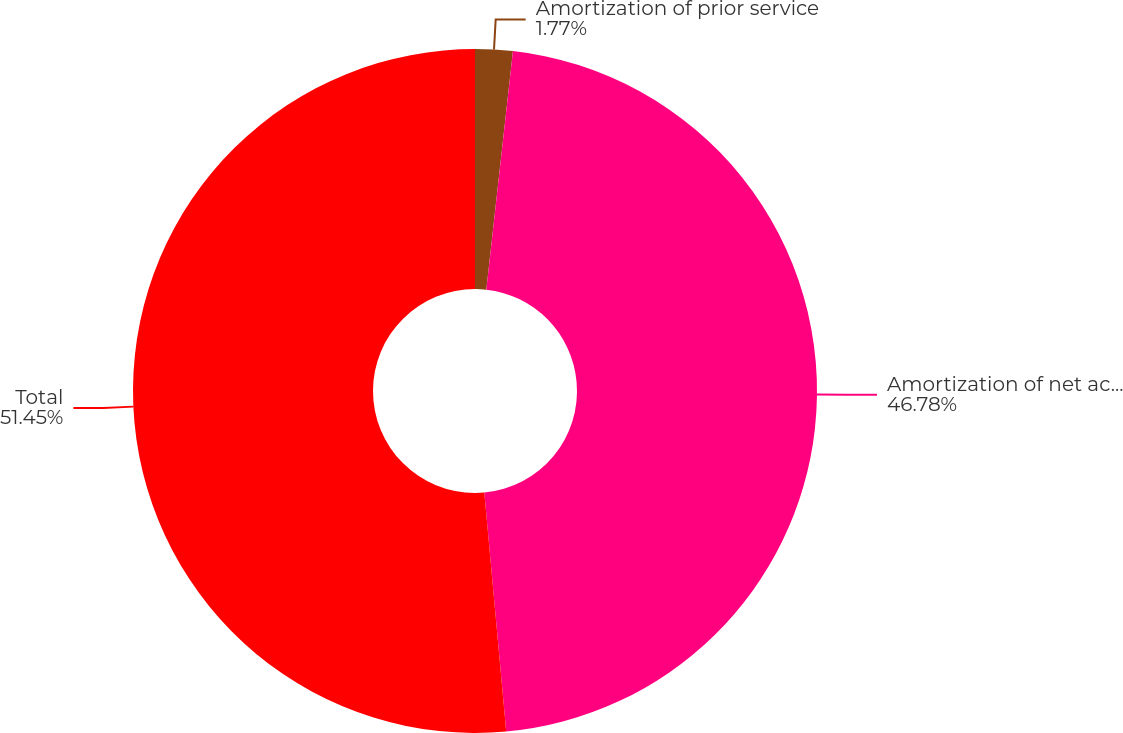Convert chart. <chart><loc_0><loc_0><loc_500><loc_500><pie_chart><fcel>Amortization of prior service<fcel>Amortization of net actuarial<fcel>Total<nl><fcel>1.77%<fcel>46.78%<fcel>51.46%<nl></chart> 